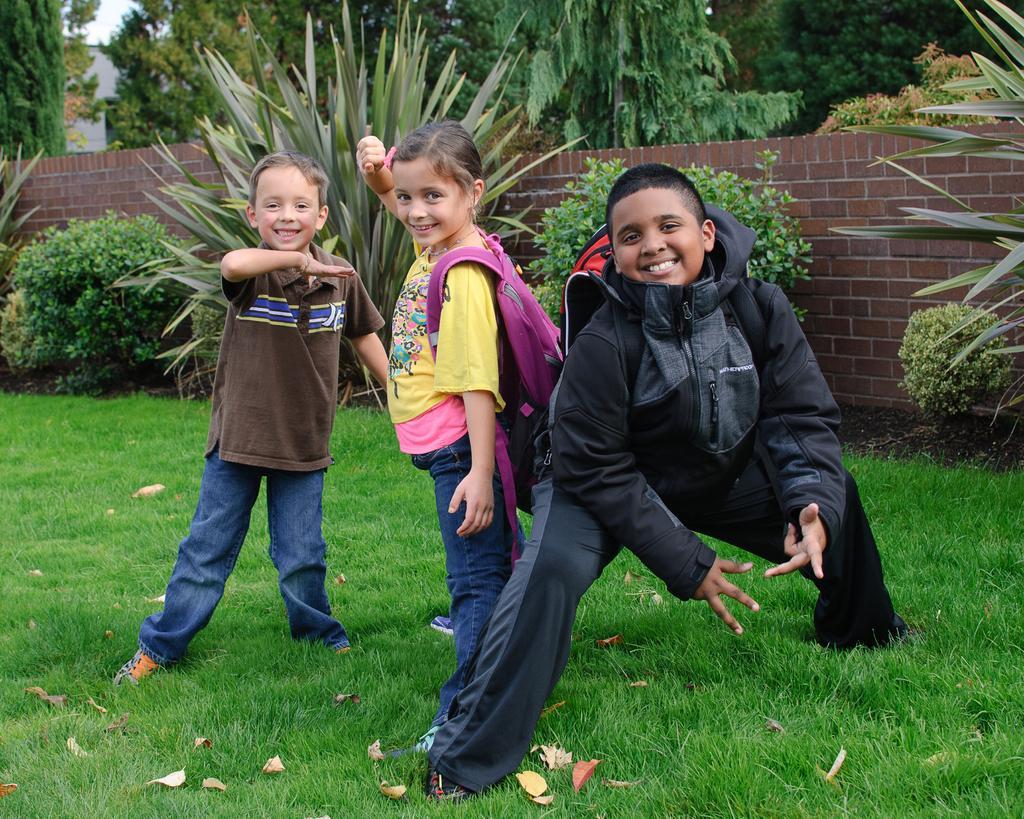Describe this image in one or two sentences. In this picture we can see two boys and a girl on the grass and smiling and a girl, boy carrying bags and in the background we can see plants, wall, trees, building, sky. 